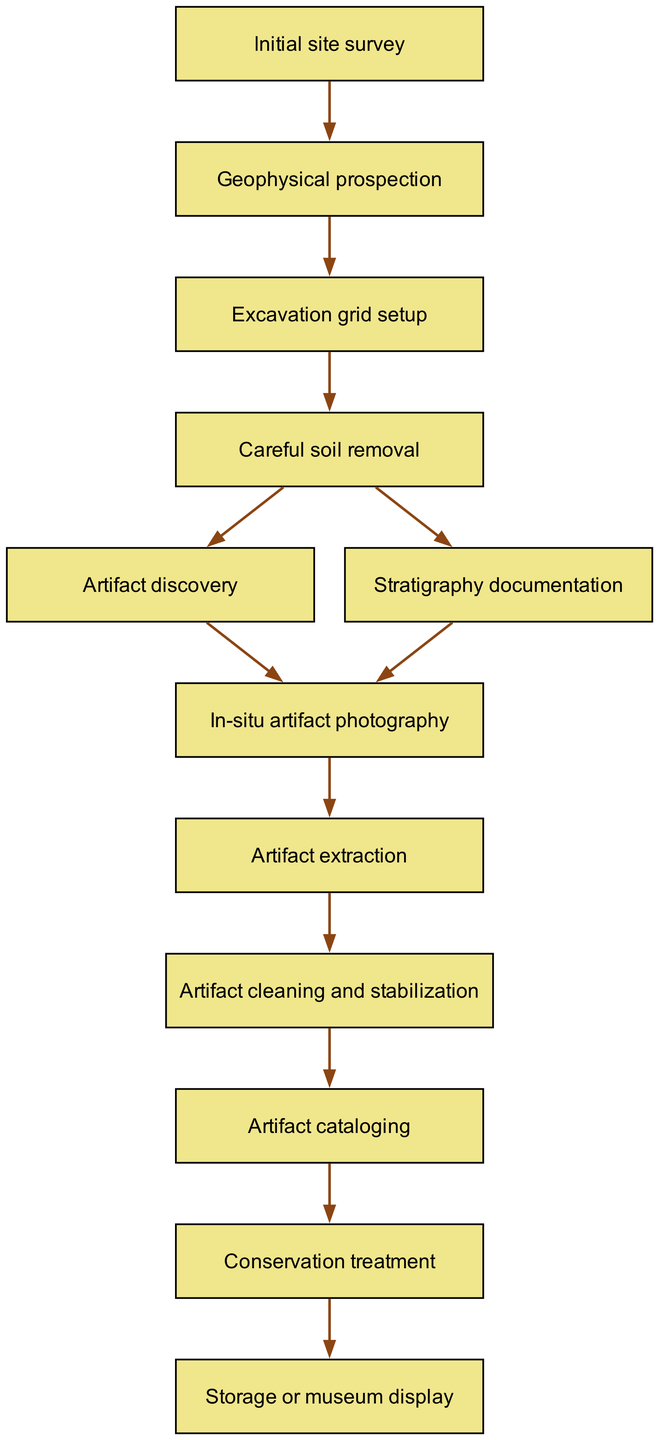What is the first step in the excavation process? The diagram starts with the node labeled "Initial site survey," indicating that this is the first step of the excavation process.
Answer: Initial site survey How many steps are there in the excavation process? By counting all the nodes in the diagram, there are twelve steps from "Initial site survey" to "Storage or museum display," which are all the nodes listed.
Answer: 12 What step follows "Careful soil removal"? The step that comes after "Careful soil removal" has two branches; it can lead to either "Artifact discovery" or "Stratigraphy documentation." However, we are looking for the direct next step in a single line of flow, which is "Artifact discovery."
Answer: Artifact discovery Which step involves taking photographs of artifacts? The diagram indicates that the step where artifacts are photographed is labeled "In-situ artifact photography," making it clear that this is the specific step for photography.
Answer: In-situ artifact photography What is the last step of the excavation process as presented in the flow chart? The final node in the flow chart is titled "Storage or museum display," representing the concluding action in the process after all previous steps have been completed.
Answer: Storage or museum display What are the two branches that follow "Careful soil removal"? The two branches that can occur after "Careful soil removal" are "Artifact discovery" and "Stratigraphy documentation." This indicates two possible paths in the workflow after this step.
Answer: Artifact discovery and Stratigraphy documentation What is the purpose of the "Artifact cleaning and stabilization" step? The step labeled "Artifact cleaning and stabilization" likely refers to the process of preparing artifacts for preservation and study, although the flow chart does not provide a detailed description beyond its title.
Answer: Artifact cleaning and stabilization What is the relationship between "Geophysical prospection" and "Excavation grid setup"? The relationship is that "Geophysical prospection" directly precedes "Excavation grid setup," indicating that the data obtained from prospection informs the creation of the excavation grid.
Answer: Directly precedes 